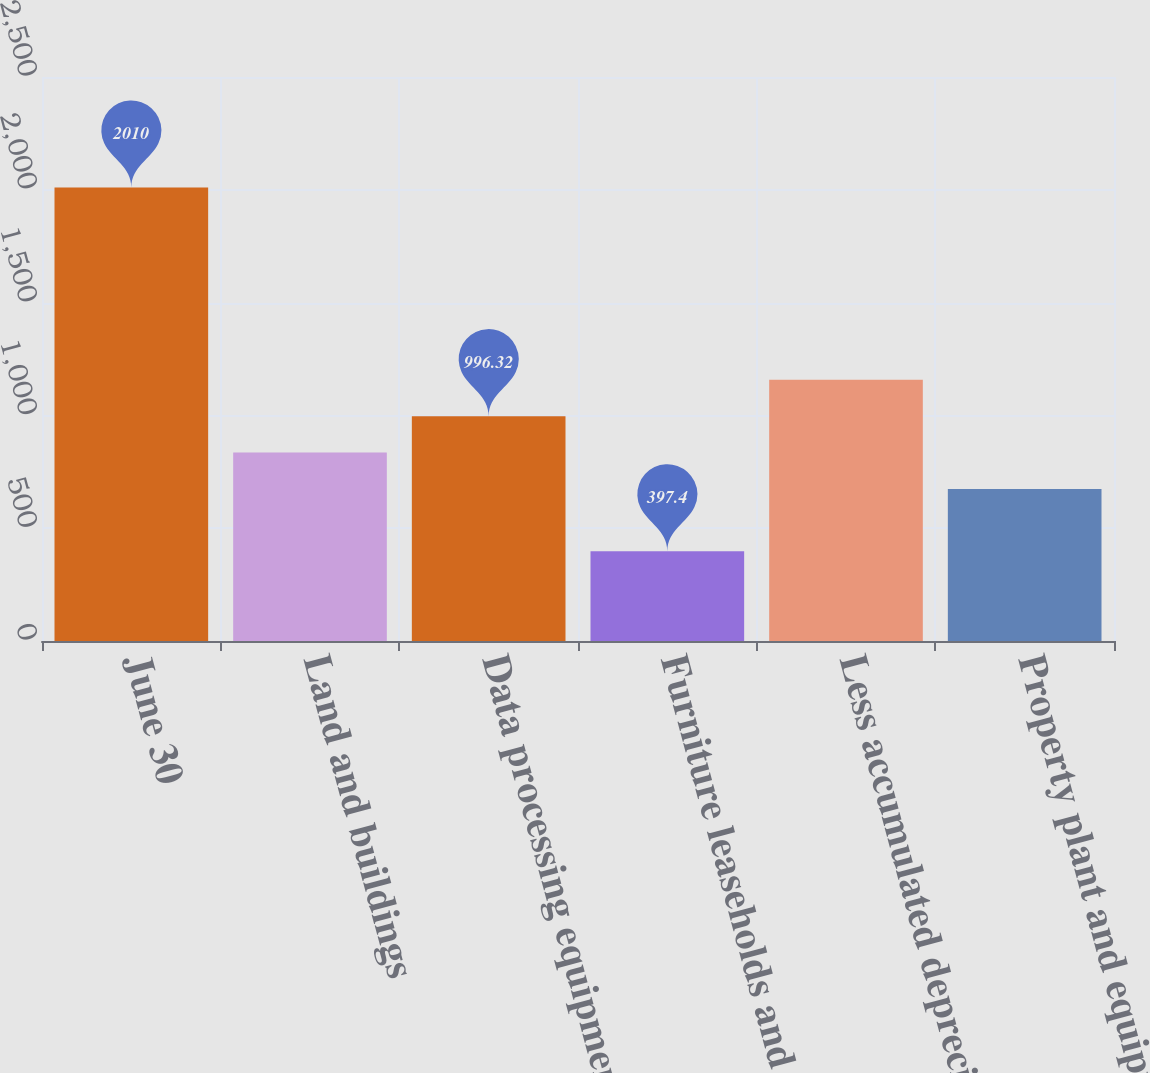Convert chart to OTSL. <chart><loc_0><loc_0><loc_500><loc_500><bar_chart><fcel>June 30<fcel>Land and buildings<fcel>Data processing equipment<fcel>Furniture leaseholds and other<fcel>Less accumulated depreciation<fcel>Property plant and equipment<nl><fcel>2010<fcel>835.06<fcel>996.32<fcel>397.4<fcel>1157.58<fcel>673.8<nl></chart> 